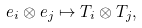Convert formula to latex. <formula><loc_0><loc_0><loc_500><loc_500>e _ { i } \otimes e _ { j } \mapsto T _ { i } \otimes T _ { j } ,</formula> 